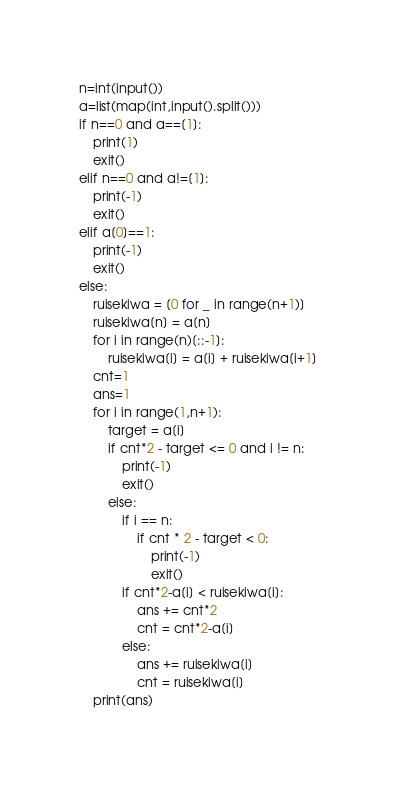<code> <loc_0><loc_0><loc_500><loc_500><_Python_>n=int(input())
a=list(map(int,input().split()))
if n==0 and a==[1]:
	print(1)
	exit()
elif n==0 and a!=[1]:
	print(-1)
	exit()
elif a[0]==1:
	print(-1)
	exit()
else:
	ruisekiwa = [0 for _ in range(n+1)]
	ruisekiwa[n] = a[n]
	for i in range(n)[::-1]:
		ruisekiwa[i] = a[i] + ruisekiwa[i+1]
	cnt=1
	ans=1
	for i in range(1,n+1):
		target = a[i]
		if cnt*2 - target <= 0 and i != n:
			print(-1)
			exit()
		else:
			if i == n:
				if cnt * 2 - target < 0:
					print(-1)
					exit()
			if cnt*2-a[i] < ruisekiwa[i]:
				ans += cnt*2
				cnt = cnt*2-a[i]
			else:
				ans += ruisekiwa[i]
				cnt = ruisekiwa[i]
	print(ans)</code> 